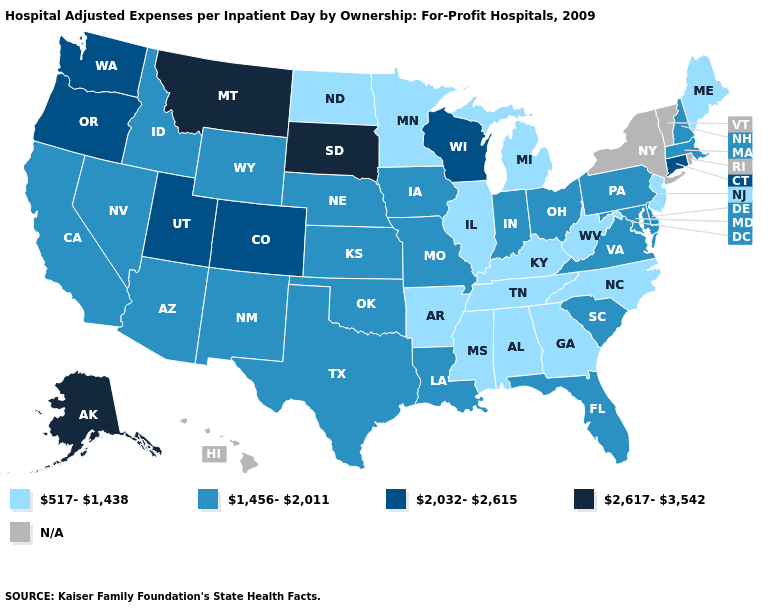Is the legend a continuous bar?
Give a very brief answer. No. Among the states that border Nebraska , which have the highest value?
Write a very short answer. South Dakota. Name the states that have a value in the range 517-1,438?
Give a very brief answer. Alabama, Arkansas, Georgia, Illinois, Kentucky, Maine, Michigan, Minnesota, Mississippi, New Jersey, North Carolina, North Dakota, Tennessee, West Virginia. Name the states that have a value in the range N/A?
Concise answer only. Hawaii, New York, Rhode Island, Vermont. Name the states that have a value in the range N/A?
Answer briefly. Hawaii, New York, Rhode Island, Vermont. Name the states that have a value in the range 2,032-2,615?
Write a very short answer. Colorado, Connecticut, Oregon, Utah, Washington, Wisconsin. Is the legend a continuous bar?
Give a very brief answer. No. What is the lowest value in the USA?
Be succinct. 517-1,438. Name the states that have a value in the range 2,032-2,615?
Concise answer only. Colorado, Connecticut, Oregon, Utah, Washington, Wisconsin. What is the value of Wisconsin?
Keep it brief. 2,032-2,615. Name the states that have a value in the range 2,032-2,615?
Be succinct. Colorado, Connecticut, Oregon, Utah, Washington, Wisconsin. What is the lowest value in the USA?
Write a very short answer. 517-1,438. What is the value of Utah?
Be succinct. 2,032-2,615. Is the legend a continuous bar?
Write a very short answer. No. 